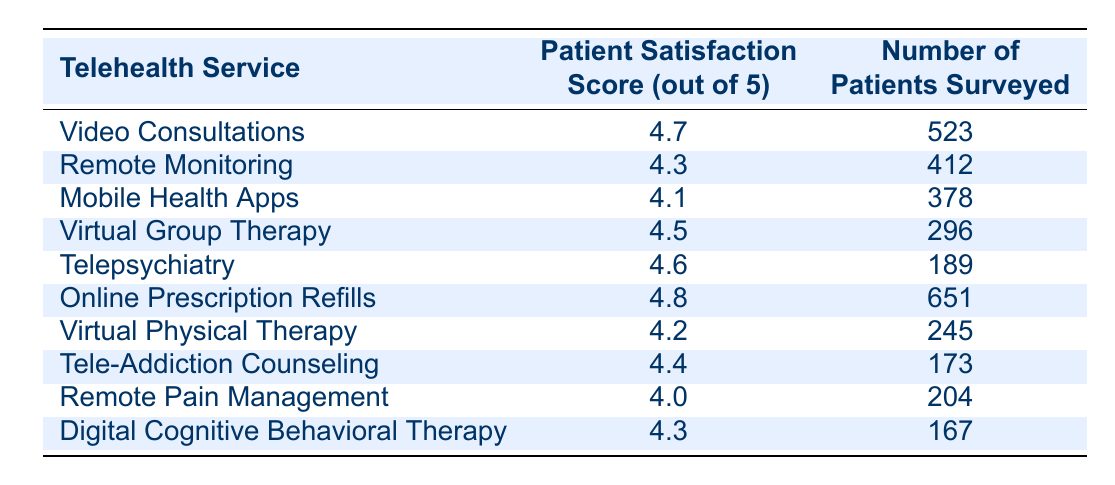What's the highest patient satisfaction score among the telehealth services? By reviewing the table, we can see that the highest score listed is 4.8 for Online Prescription Refills.
Answer: 4.8 What is the patient satisfaction score for Telepsychiatry? The table indicates that the satisfaction score for Telepsychiatry is 4.6.
Answer: 4.6 How many patients were surveyed for Virtual Group Therapy? According to the table, 296 patients were surveyed for Virtual Group Therapy.
Answer: 296 Which telehealth service has the lowest patient satisfaction score? The lowest satisfaction score listed is for Remote Pain Management, with a score of 4.0.
Answer: Remote Pain Management What is the average satisfaction score for all services listed? To find the average, we sum the scores: (4.7 + 4.3 + 4.1 + 4.5 + 4.6 + 4.8 + 4.2 + 4.4 + 4.0 + 4.3) = 44.9. There are 10 services, so we divide 44.9 by 10 to get the average of 4.49.
Answer: 4.49 Are more patients surveyed for Video Consultations than for Tele-Addiction Counseling? The table shows 523 patients were surveyed for Video Consultations and 173 for Tele-Addiction Counseling. Since 523 is greater than 173, the answer is yes.
Answer: Yes Is there a telehealth service with a patient satisfaction score of exactly 4.5? Looking at the table, Virtual Group Therapy has a score of 4.5, confirming the statement is true.
Answer: Yes How many more patients were surveyed for Online Prescription Refills compared to Virtual Physical Therapy? Online Prescription Refills had 651 patients surveyed, while Virtual Physical Therapy had 245. The difference is 651 - 245 = 406.
Answer: 406 Which two services have patient satisfaction scores that average to more than 4.5? The services with scores of 4.7 (Video Consultations) and 4.8 (Online Prescription Refills) can be considered. Their average is (4.7 + 4.8) / 2 = 4.75, which is more than 4.5.
Answer: Video Consultations and Online Prescription Refills What is the satisfaction score range from the highest to the lowest service? The highest score is 4.8 (Online Prescription Refills) and the lowest is 4.0 (Remote Pain Management). The range is 4.8 - 4.0 = 0.8.
Answer: 0.8 